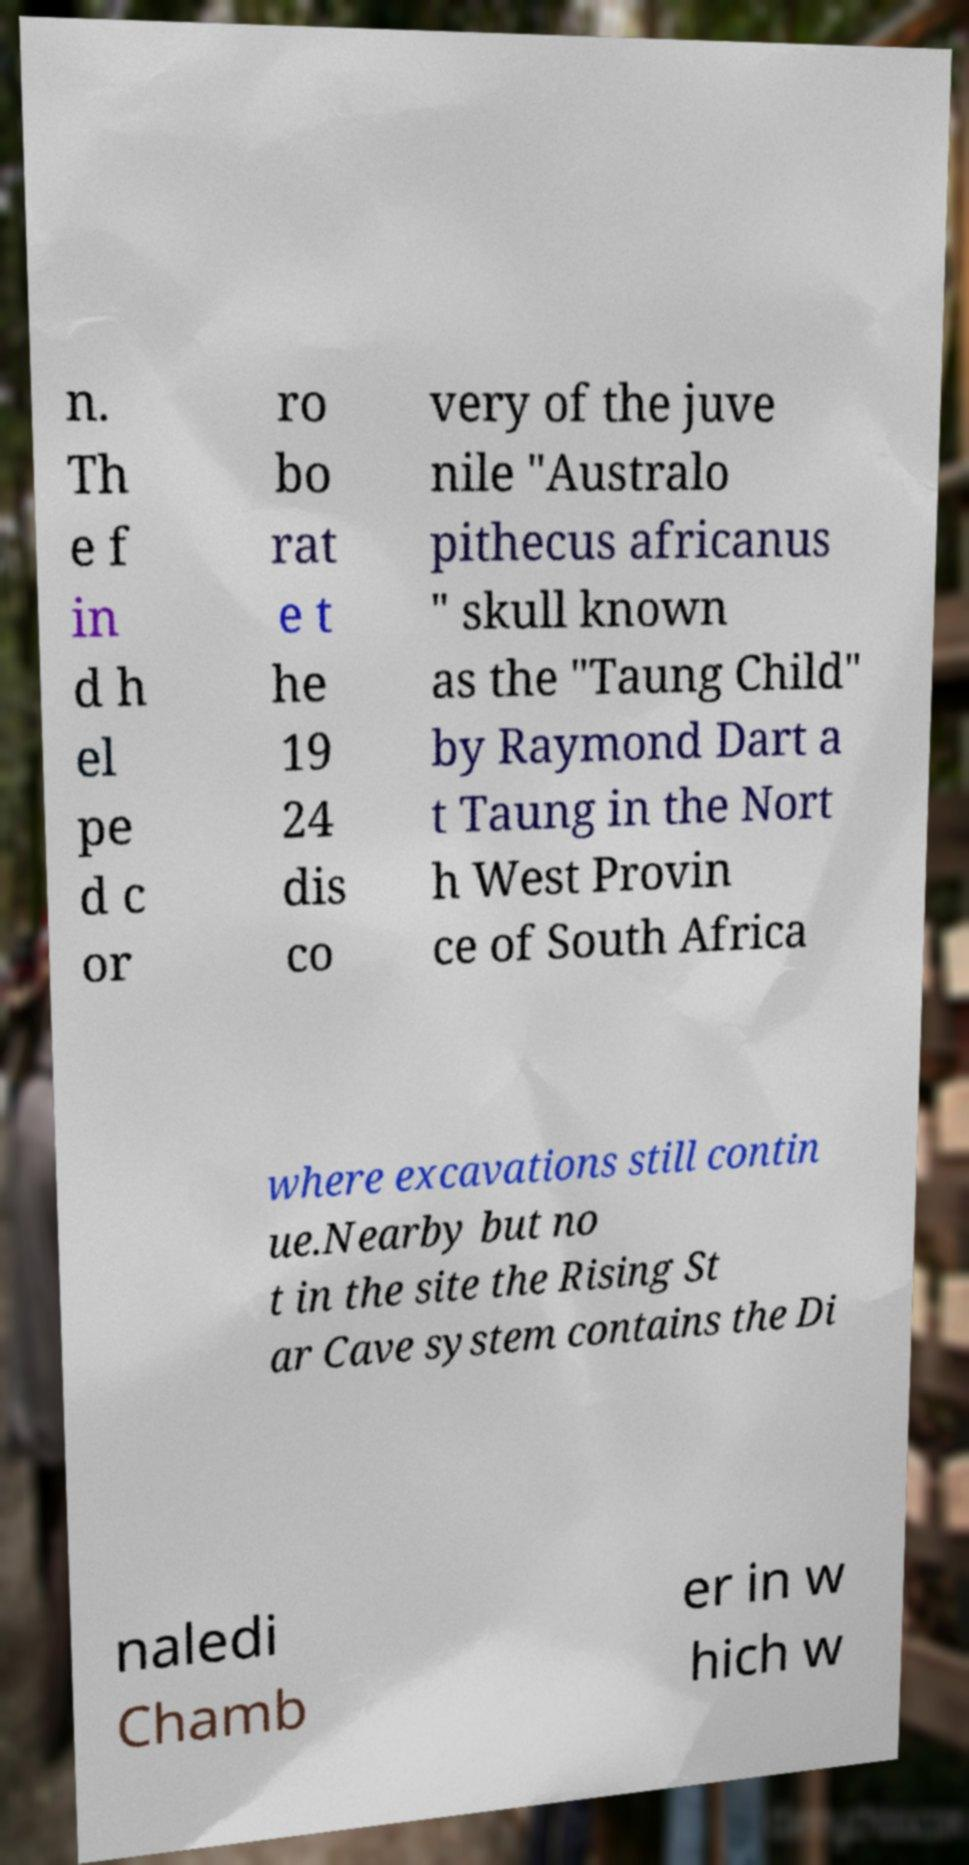Could you assist in decoding the text presented in this image and type it out clearly? n. Th e f in d h el pe d c or ro bo rat e t he 19 24 dis co very of the juve nile "Australo pithecus africanus " skull known as the "Taung Child" by Raymond Dart a t Taung in the Nort h West Provin ce of South Africa where excavations still contin ue.Nearby but no t in the site the Rising St ar Cave system contains the Di naledi Chamb er in w hich w 